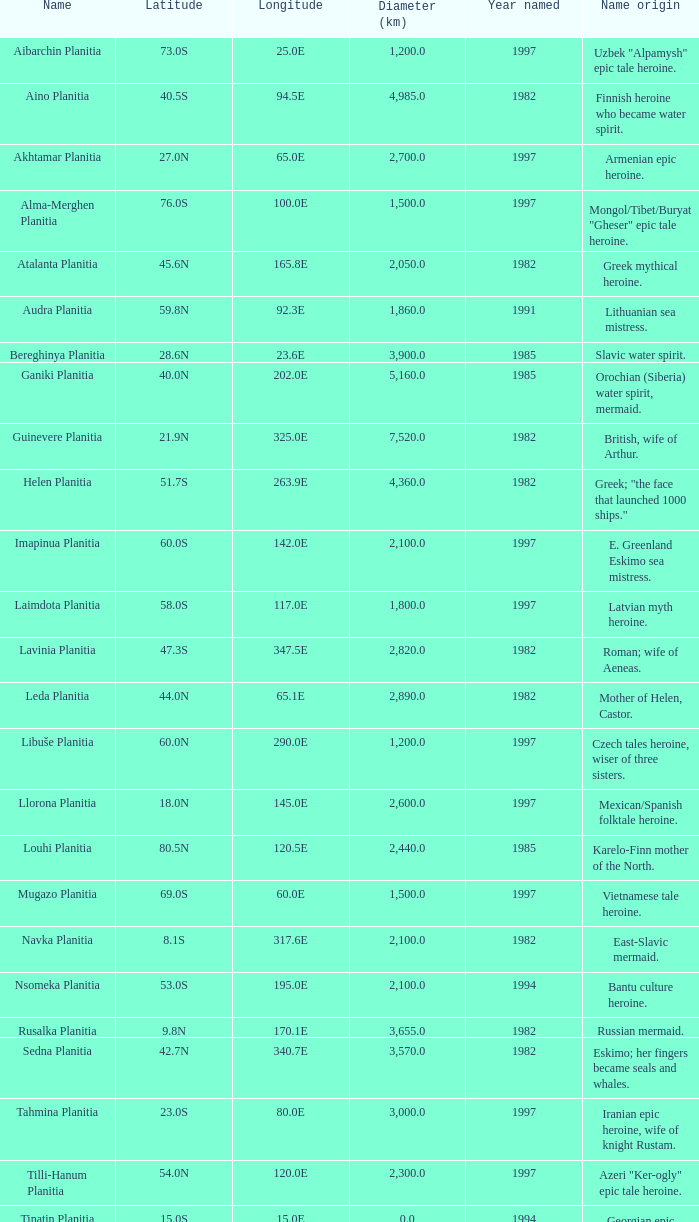What is the latitude of the element located at longitude 8 23.0S. 